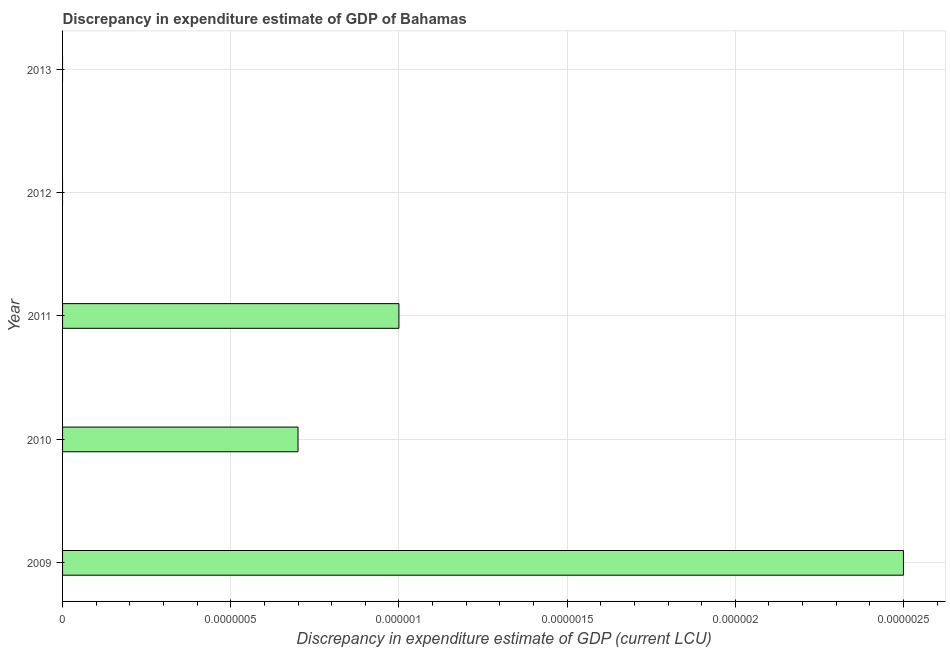Does the graph contain any zero values?
Ensure brevity in your answer.  Yes. Does the graph contain grids?
Make the answer very short. Yes. What is the title of the graph?
Provide a succinct answer. Discrepancy in expenditure estimate of GDP of Bahamas. What is the label or title of the X-axis?
Your answer should be compact. Discrepancy in expenditure estimate of GDP (current LCU). What is the label or title of the Y-axis?
Offer a very short reply. Year. What is the discrepancy in expenditure estimate of gdp in 2010?
Make the answer very short. 7e-7. Across all years, what is the maximum discrepancy in expenditure estimate of gdp?
Make the answer very short. 2.5e-6. In which year was the discrepancy in expenditure estimate of gdp maximum?
Provide a short and direct response. 2009. What is the sum of the discrepancy in expenditure estimate of gdp?
Provide a succinct answer. 4.2000000000000004e-6. What is the median discrepancy in expenditure estimate of gdp?
Provide a succinct answer. 7e-7. What is the ratio of the discrepancy in expenditure estimate of gdp in 2009 to that in 2010?
Your answer should be very brief. 3.57. What is the difference between the highest and the second highest discrepancy in expenditure estimate of gdp?
Your answer should be compact. 0. What is the difference between the highest and the lowest discrepancy in expenditure estimate of gdp?
Offer a very short reply. 0. How many years are there in the graph?
Make the answer very short. 5. What is the difference between two consecutive major ticks on the X-axis?
Offer a very short reply. 5e-7. What is the Discrepancy in expenditure estimate of GDP (current LCU) in 2009?
Give a very brief answer. 2.5e-6. What is the Discrepancy in expenditure estimate of GDP (current LCU) of 2010?
Your response must be concise. 7e-7. What is the Discrepancy in expenditure estimate of GDP (current LCU) of 2011?
Ensure brevity in your answer.  1e-6. What is the difference between the Discrepancy in expenditure estimate of GDP (current LCU) in 2009 and 2011?
Your answer should be compact. 0. What is the difference between the Discrepancy in expenditure estimate of GDP (current LCU) in 2010 and 2011?
Keep it short and to the point. -0. What is the ratio of the Discrepancy in expenditure estimate of GDP (current LCU) in 2009 to that in 2010?
Keep it short and to the point. 3.57. What is the ratio of the Discrepancy in expenditure estimate of GDP (current LCU) in 2009 to that in 2011?
Provide a short and direct response. 2.5. 